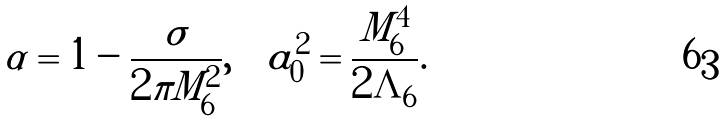Convert formula to latex. <formula><loc_0><loc_0><loc_500><loc_500>\alpha = 1 - \frac { \sigma } { 2 \pi M _ { 6 } ^ { 2 } } , \quad a _ { 0 } ^ { 2 } = \frac { M _ { 6 } ^ { 4 } } { 2 \Lambda _ { 6 } } .</formula> 